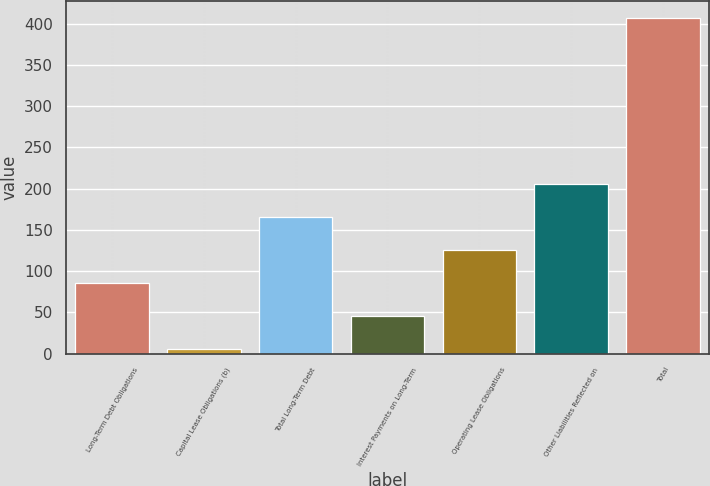Convert chart. <chart><loc_0><loc_0><loc_500><loc_500><bar_chart><fcel>Long-Term Debt Obligations<fcel>Capital Lease Obligations (b)<fcel>Total Long-Term Debt<fcel>Interest Payments on Long-Term<fcel>Operating Lease Obligations<fcel>Other Liabilities Reflected on<fcel>Total<nl><fcel>85.32<fcel>5<fcel>165.64<fcel>45.16<fcel>125.48<fcel>205.8<fcel>406.6<nl></chart> 